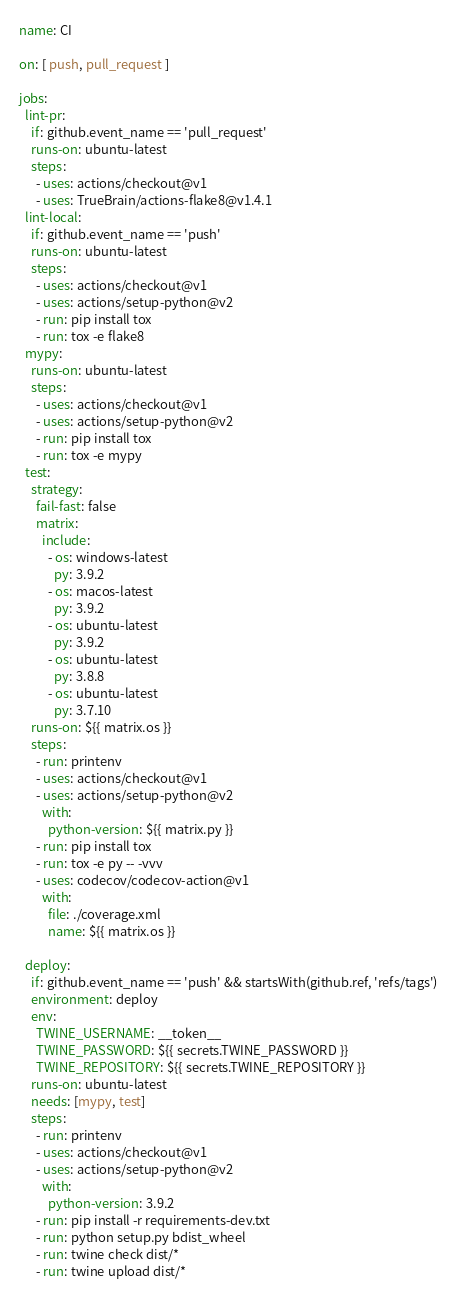<code> <loc_0><loc_0><loc_500><loc_500><_YAML_>name: CI

on: [ push, pull_request ]

jobs:
  lint-pr:
    if: github.event_name == 'pull_request'
    runs-on: ubuntu-latest
    steps:
      - uses: actions/checkout@v1
      - uses: TrueBrain/actions-flake8@v1.4.1
  lint-local:
    if: github.event_name == 'push'
    runs-on: ubuntu-latest
    steps:
      - uses: actions/checkout@v1
      - uses: actions/setup-python@v2
      - run: pip install tox
      - run: tox -e flake8
  mypy:
    runs-on: ubuntu-latest
    steps:
      - uses: actions/checkout@v1
      - uses: actions/setup-python@v2
      - run: pip install tox
      - run: tox -e mypy
  test:
    strategy:
      fail-fast: false
      matrix:
        include:
          - os: windows-latest
            py: 3.9.2
          - os: macos-latest
            py: 3.9.2
          - os: ubuntu-latest
            py: 3.9.2
          - os: ubuntu-latest
            py: 3.8.8
          - os: ubuntu-latest
            py: 3.7.10
    runs-on: ${{ matrix.os }}
    steps:
      - run: printenv
      - uses: actions/checkout@v1
      - uses: actions/setup-python@v2
        with:
          python-version: ${{ matrix.py }}
      - run: pip install tox
      - run: tox -e py -- -vvv
      - uses: codecov/codecov-action@v1
        with:
          file: ./coverage.xml
          name: ${{ matrix.os }}

  deploy:
    if: github.event_name == 'push' && startsWith(github.ref, 'refs/tags')
    environment: deploy
    env:
      TWINE_USERNAME: __token__
      TWINE_PASSWORD: ${{ secrets.TWINE_PASSWORD }}
      TWINE_REPOSITORY: ${{ secrets.TWINE_REPOSITORY }}
    runs-on: ubuntu-latest
    needs: [mypy, test]
    steps:
      - run: printenv
      - uses: actions/checkout@v1
      - uses: actions/setup-python@v2
        with:
          python-version: 3.9.2
      - run: pip install -r requirements-dev.txt
      - run: python setup.py bdist_wheel
      - run: twine check dist/*
      - run: twine upload dist/*
</code> 